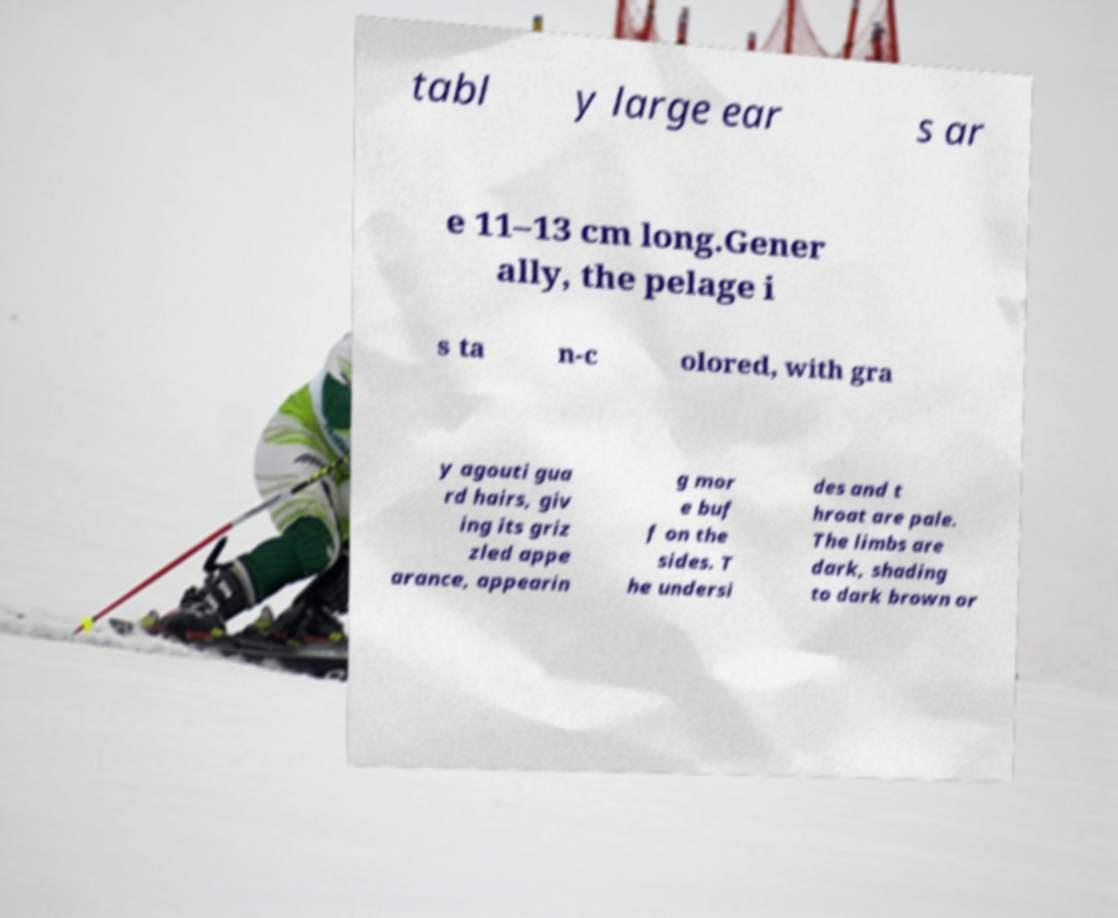There's text embedded in this image that I need extracted. Can you transcribe it verbatim? tabl y large ear s ar e 11–13 cm long.Gener ally, the pelage i s ta n-c olored, with gra y agouti gua rd hairs, giv ing its griz zled appe arance, appearin g mor e buf f on the sides. T he undersi des and t hroat are pale. The limbs are dark, shading to dark brown or 